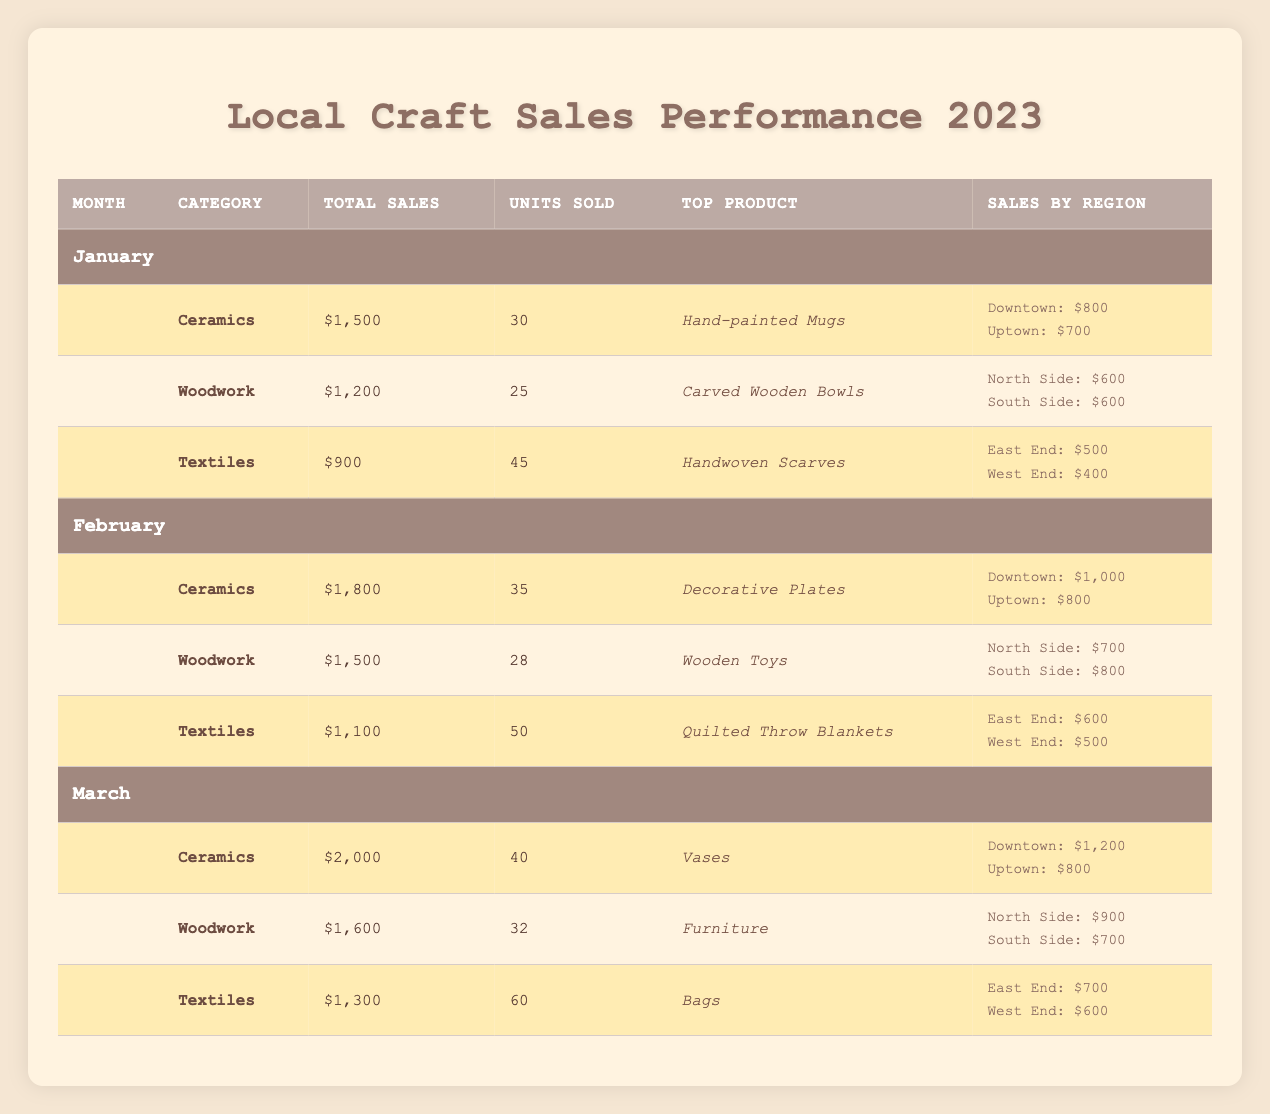What is the top product sold in ceramics for February? The table lists the top product for ceramics in February as "Decorative Plates".
Answer: Decorative Plates How many units of textiles were sold in January? The table indicates that 45 units of textiles were sold in January.
Answer: 45 Which category had the highest total sales in March? In March, ceramics had total sales of $2,000, woodwork had $1,600, and textiles had $1,300. Ceramics had the highest total sales.
Answer: Ceramics What was the total sales for woodwork in January and February combined? The total sales for woodwork in January was $1,200 and in February was $1,500. So, adding these together gives $1,200 + $1,500 = $2,700.
Answer: $2,700 Did any category have more units sold in February than in January? In January, textiles sold 45 units, but in February it sold 50 units, which is more than January. Also, ceramics had 35 units sold in February compared to 30 in January. Therefore, yes, both ceramics and textiles sold more units in February.
Answer: Yes What is the average total sales for ceramics across the three months? The total sales for ceramics are $1,500 (January), $1,800 (February), and $2,000 (March). To find the average: (1,500 + 1,800 + 2,000) / 3 = 1,766.67.
Answer: $1,766.67 How much were the total sales for the North Side region in January? The total sales for North Side in January for woodwork were $600, and for ceramics, there were no sales reported for that region. Therefore, the total is $600.
Answer: $600 Which month had the highest sales in textiles? Looking at the sales data, January had $900, February had $1,100, and March had $1,300 in textiles. March had the highest sales at $1,300.
Answer: March What is the difference in sales between the top-selling product in March and January for ceramics? The top-selling product in January was "Hand-painted Mugs" with $1,500 and in March was "Vases" with $2,000. The difference in sales is $2,000 - $1,500 = $500.
Answer: $500 